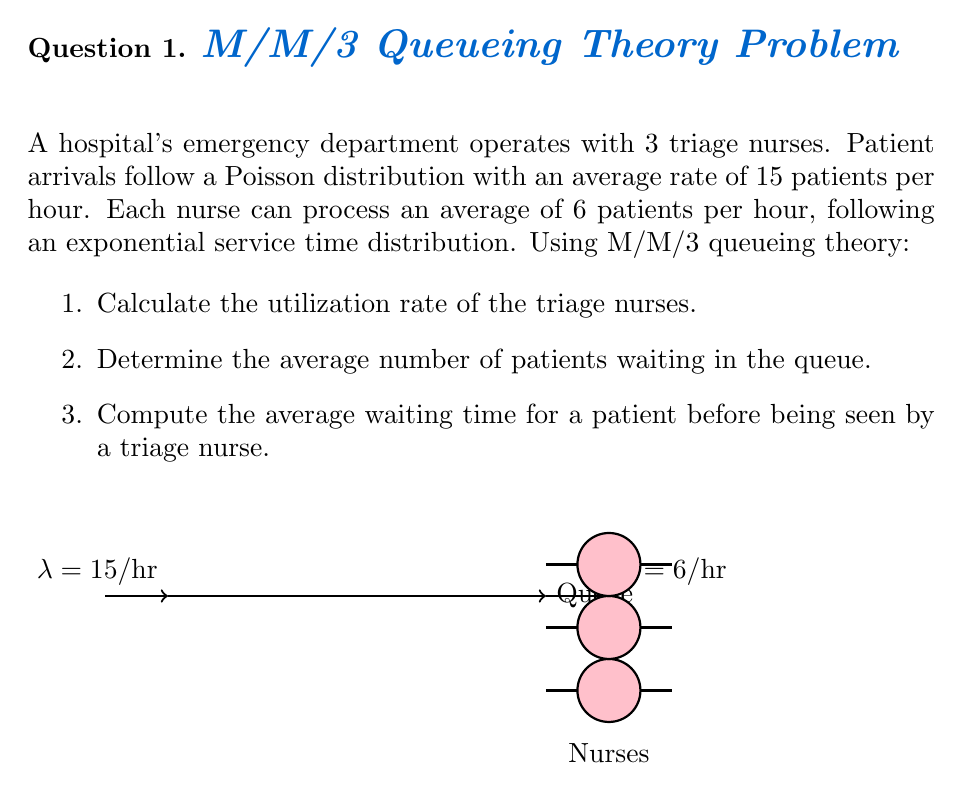Can you answer this question? Let's solve this problem step by step using M/M/3 queueing theory:

1. Utilization rate (ρ):
   The utilization rate is given by ρ = λ / (c * μ), where:
   λ = arrival rate = 15 patients/hour
   μ = service rate per nurse = 6 patients/hour
   c = number of nurses = 3

   $$\rho = \frac{15}{3 * 6} = \frac{15}{18} = \frac{5}{6} \approx 0.8333$$

2. Average number of patients in the queue (Lq):
   For an M/M/c system, we use the Erlang C formula:

   $$L_q = \frac{(c\rho)^c \rho}{c!(1-\rho)^2} \cdot P_0$$

   Where $P_0$ is the probability of an empty system:

   $$P_0 = \left[\sum_{n=0}^{c-1}\frac{(c\rho)^n}{n!} + \frac{(c\rho)^c}{c!(1-\rho)}\right]^{-1}$$

   Calculating $P_0$:
   $$P_0 = \left[1 + \frac{15}{1!} + \frac{15^2}{2!} + \frac{15^3}{3!(1-\frac{5}{6})}\right]^{-1} \approx 0.00392$$

   Now we can calculate $L_q$:
   $$L_q = \frac{(3 * \frac{5}{6})^3 * \frac{5}{6}}{3!(1-\frac{5}{6})^2} * 0.00392 \approx 2.0833$$

3. Average waiting time (Wq):
   Using Little's Law, we can calculate the average waiting time:

   $$W_q = \frac{L_q}{\lambda}$$

   $$W_q = \frac{2.0833}{15} \approx 0.1389 \text{ hours} = 8.33 \text{ minutes}$$
Answer: 1. ρ ≈ 0.8333
2. Lq ≈ 2.0833 patients
3. Wq ≈ 8.33 minutes 